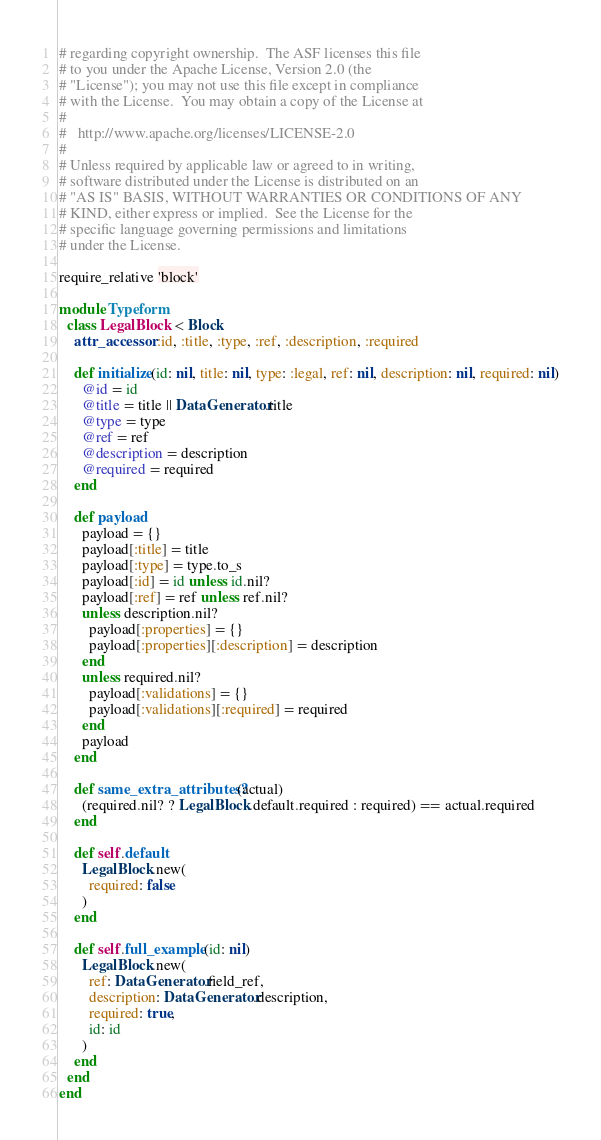<code> <loc_0><loc_0><loc_500><loc_500><_Ruby_># regarding copyright ownership.  The ASF licenses this file
# to you under the Apache License, Version 2.0 (the
# "License"); you may not use this file except in compliance
# with the License.  You may obtain a copy of the License at
#
#   http://www.apache.org/licenses/LICENSE-2.0
#
# Unless required by applicable law or agreed to in writing,
# software distributed under the License is distributed on an
# "AS IS" BASIS, WITHOUT WARRANTIES OR CONDITIONS OF ANY
# KIND, either express or implied.  See the License for the
# specific language governing permissions and limitations
# under the License.

require_relative 'block'

module Typeform
  class LegalBlock < Block
    attr_accessor :id, :title, :type, :ref, :description, :required

    def initialize(id: nil, title: nil, type: :legal, ref: nil, description: nil, required: nil)
      @id = id
      @title = title || DataGenerator.title
      @type = type
      @ref = ref
      @description = description
      @required = required
    end

    def payload
      payload = {}
      payload[:title] = title
      payload[:type] = type.to_s
      payload[:id] = id unless id.nil?
      payload[:ref] = ref unless ref.nil?
      unless description.nil?
        payload[:properties] = {}
        payload[:properties][:description] = description
      end
      unless required.nil?
        payload[:validations] = {}
        payload[:validations][:required] = required
      end
      payload
    end

    def same_extra_attributes?(actual)
      (required.nil? ? LegalBlock.default.required : required) == actual.required
    end

    def self.default
      LegalBlock.new(
        required: false
      )
    end

    def self.full_example(id: nil)
      LegalBlock.new(
        ref: DataGenerator.field_ref,
        description: DataGenerator.description,
        required: true,
        id: id
      )
    end
  end
end
</code> 